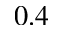<formula> <loc_0><loc_0><loc_500><loc_500>0 . 4</formula> 